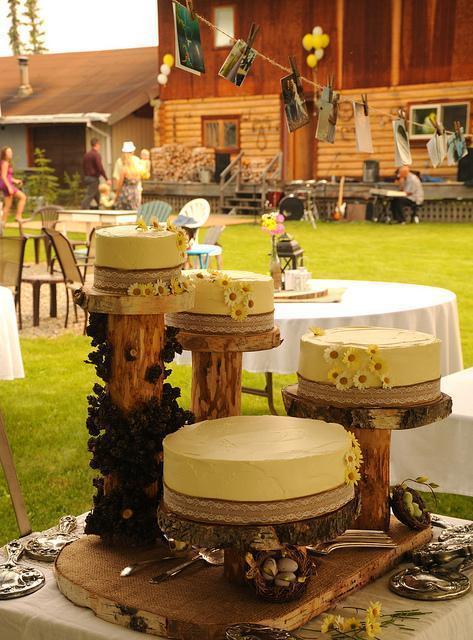How many dining tables can you see?
Give a very brief answer. 3. How many cakes can be seen?
Give a very brief answer. 4. How many motorcycles are there in the image?
Give a very brief answer. 0. 